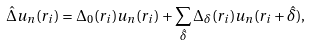Convert formula to latex. <formula><loc_0><loc_0><loc_500><loc_500>\hat { \Delta } u _ { n } ( r _ { i } ) = \Delta _ { 0 } ( r _ { i } ) u _ { n } ( r _ { i } ) + \sum _ { \hat { \delta } } \Delta _ { \delta } ( r _ { i } ) u _ { n } ( r _ { i } + \hat { \delta } ) ,</formula> 